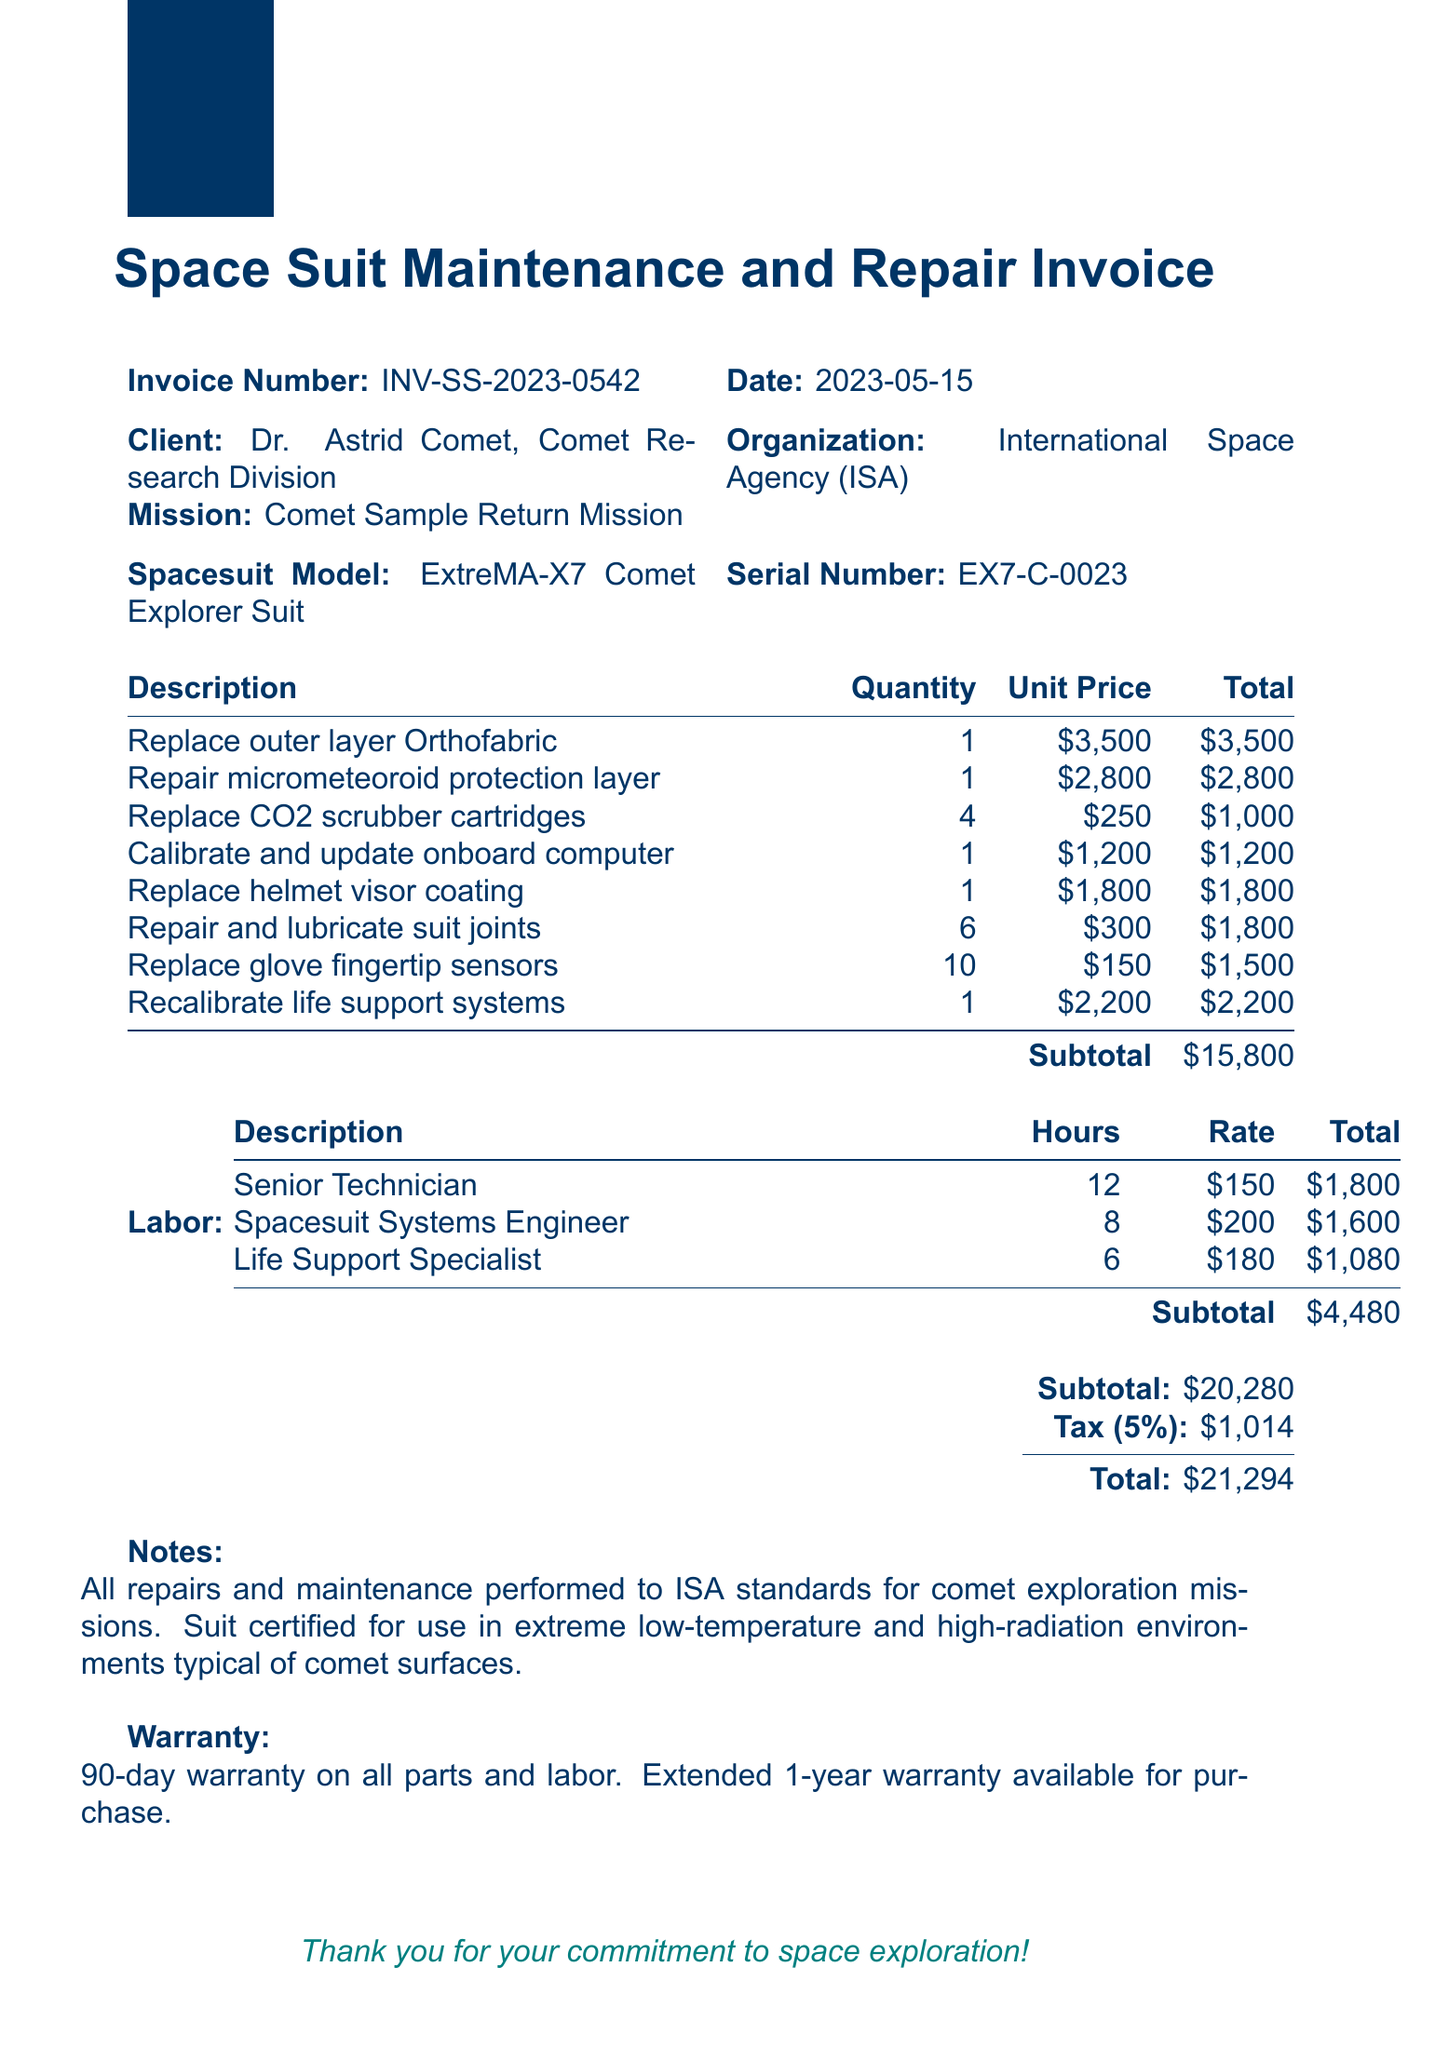What is the invoice number? The invoice number is clearly stated at the top of the document, which is INV-SS-2023-0542.
Answer: INV-SS-2023-0542 Who is the client? The document mentions the client in the relevant section, which is Dr. Astrid Comet, Comet Research Division.
Answer: Dr. Astrid Comet, Comet Research Division What is the total amount due? The total amount due is summarized at the end of the document, which is $21,294.
Answer: $21,294 How many CO2 scrubber cartridges were replaced? The number of CO2 scrubber cartridges replaced is found in the item description section, which is 4.
Answer: 4 What is the warranty period for parts and labor? The warranty period is specified under the warranty section of the document, which states 90-day warranty.
Answer: 90-day warranty What labor cost is associated with the Senior Technician? The total labor cost for the Senior Technician is outlined in the labor section, which is $1,800.
Answer: $1,800 What is the subtotal of all repair items? The subtotal for all repair items is calculated and indicated in the document as $15,800.
Answer: $15,800 Which spacesuit model is being serviced? The model of the spacesuit is provided in the document, which is ExtreMA-X7 Comet Explorer Suit.
Answer: ExtreMA-X7 Comet Explorer Suit 